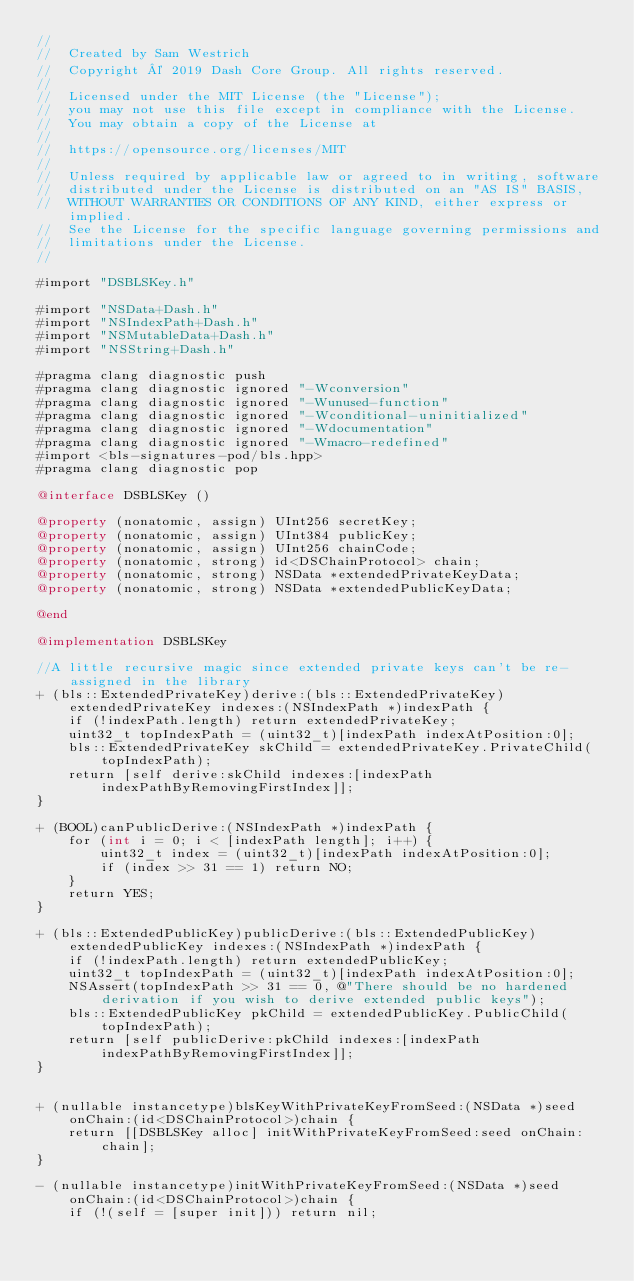<code> <loc_0><loc_0><loc_500><loc_500><_ObjectiveC_>//
//  Created by Sam Westrich
//  Copyright © 2019 Dash Core Group. All rights reserved.
//
//  Licensed under the MIT License (the "License");
//  you may not use this file except in compliance with the License.
//  You may obtain a copy of the License at
//
//  https://opensource.org/licenses/MIT
//
//  Unless required by applicable law or agreed to in writing, software
//  distributed under the License is distributed on an "AS IS" BASIS,
//  WITHOUT WARRANTIES OR CONDITIONS OF ANY KIND, either express or implied.
//  See the License for the specific language governing permissions and
//  limitations under the License.
//

#import "DSBLSKey.h"

#import "NSData+Dash.h"
#import "NSIndexPath+Dash.h"
#import "NSMutableData+Dash.h"
#import "NSString+Dash.h"

#pragma clang diagnostic push
#pragma clang diagnostic ignored "-Wconversion"
#pragma clang diagnostic ignored "-Wunused-function"
#pragma clang diagnostic ignored "-Wconditional-uninitialized"
#pragma clang diagnostic ignored "-Wdocumentation"
#pragma clang diagnostic ignored "-Wmacro-redefined"
#import <bls-signatures-pod/bls.hpp>
#pragma clang diagnostic pop

@interface DSBLSKey ()

@property (nonatomic, assign) UInt256 secretKey;
@property (nonatomic, assign) UInt384 publicKey;
@property (nonatomic, assign) UInt256 chainCode;
@property (nonatomic, strong) id<DSChainProtocol> chain;
@property (nonatomic, strong) NSData *extendedPrivateKeyData;
@property (nonatomic, strong) NSData *extendedPublicKeyData;

@end

@implementation DSBLSKey

//A little recursive magic since extended private keys can't be re-assigned in the library
+ (bls::ExtendedPrivateKey)derive:(bls::ExtendedPrivateKey)extendedPrivateKey indexes:(NSIndexPath *)indexPath {
    if (!indexPath.length) return extendedPrivateKey;
    uint32_t topIndexPath = (uint32_t)[indexPath indexAtPosition:0];
    bls::ExtendedPrivateKey skChild = extendedPrivateKey.PrivateChild(topIndexPath);
    return [self derive:skChild indexes:[indexPath indexPathByRemovingFirstIndex]];
}

+ (BOOL)canPublicDerive:(NSIndexPath *)indexPath {
    for (int i = 0; i < [indexPath length]; i++) {
        uint32_t index = (uint32_t)[indexPath indexAtPosition:0];
        if (index >> 31 == 1) return NO;
    }
    return YES;
}

+ (bls::ExtendedPublicKey)publicDerive:(bls::ExtendedPublicKey)extendedPublicKey indexes:(NSIndexPath *)indexPath {
    if (!indexPath.length) return extendedPublicKey;
    uint32_t topIndexPath = (uint32_t)[indexPath indexAtPosition:0];
    NSAssert(topIndexPath >> 31 == 0, @"There should be no hardened derivation if you wish to derive extended public keys");
    bls::ExtendedPublicKey pkChild = extendedPublicKey.PublicChild(topIndexPath);
    return [self publicDerive:pkChild indexes:[indexPath indexPathByRemovingFirstIndex]];
}


+ (nullable instancetype)blsKeyWithPrivateKeyFromSeed:(NSData *)seed onChain:(id<DSChainProtocol>)chain {
    return [[DSBLSKey alloc] initWithPrivateKeyFromSeed:seed onChain:chain];
}

- (nullable instancetype)initWithPrivateKeyFromSeed:(NSData *)seed onChain:(id<DSChainProtocol>)chain {
    if (!(self = [super init])) return nil;
</code> 